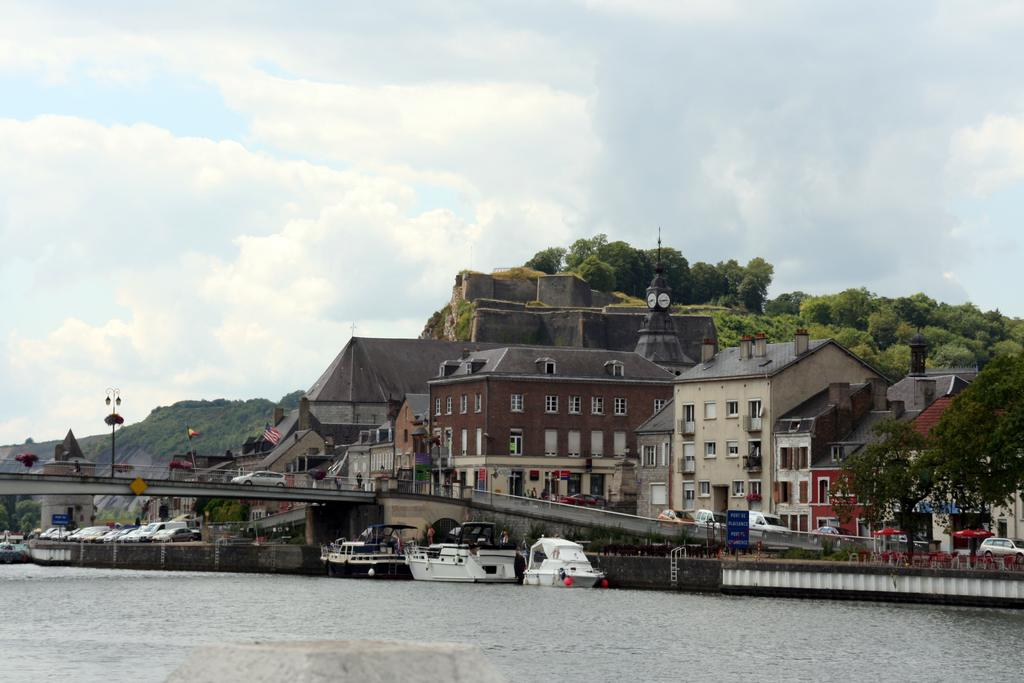What type of structures can be seen in the image? There are houses in the image. What vehicles are present in the image? There are cars in the image. What type of vegetation is visible in the image? There are trees in the image. What body of water is visible in the image? There is water visible at the bottom of the image, and ships are present in the water. What part of the natural environment is visible in the image? The sky is visible at the top of the image. How many women are present in the image? There is no woman present in the image. What type of produce can be seen growing near the houses in the image? There is no produce visible in the image; it only features houses, cars, trees, water, ships, and sky. 